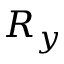<formula> <loc_0><loc_0><loc_500><loc_500>R _ { y }</formula> 